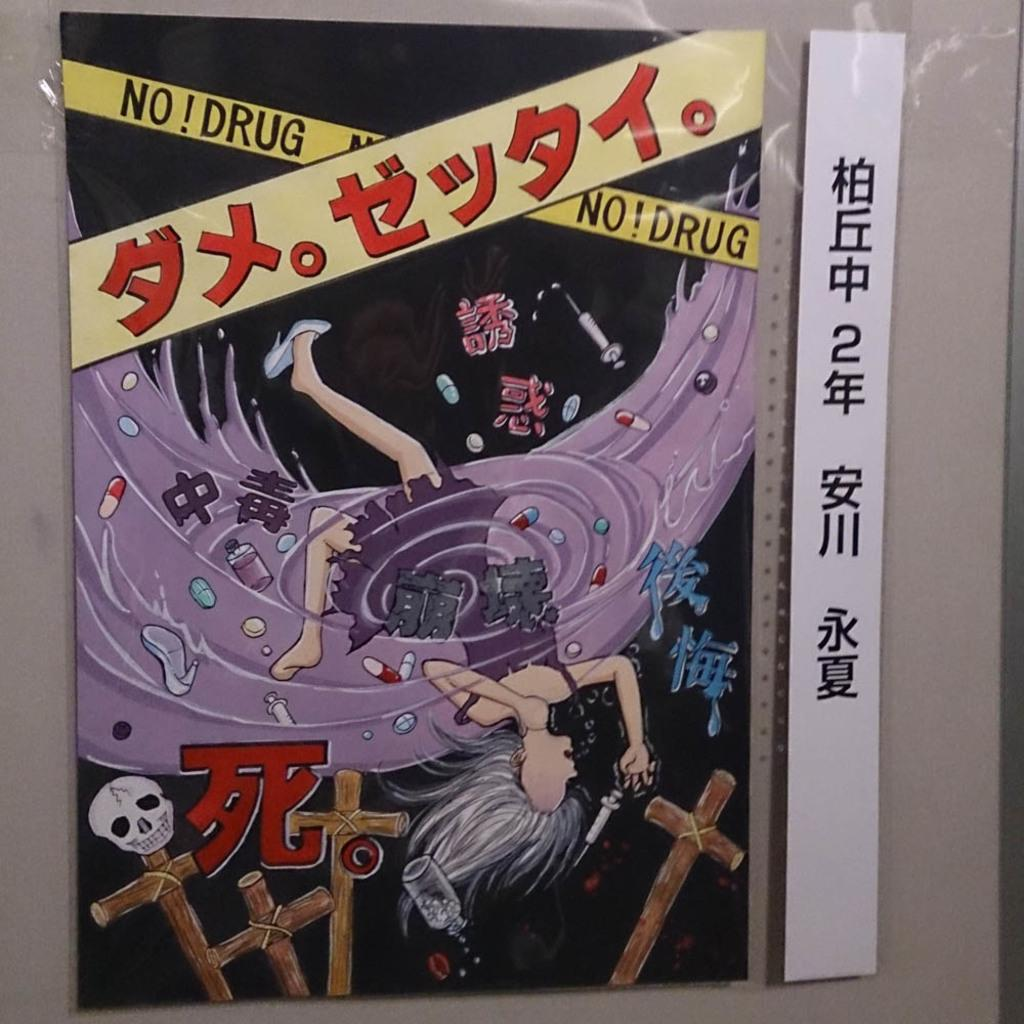<image>
Write a terse but informative summary of the picture. the word drug is on the front of the comic 